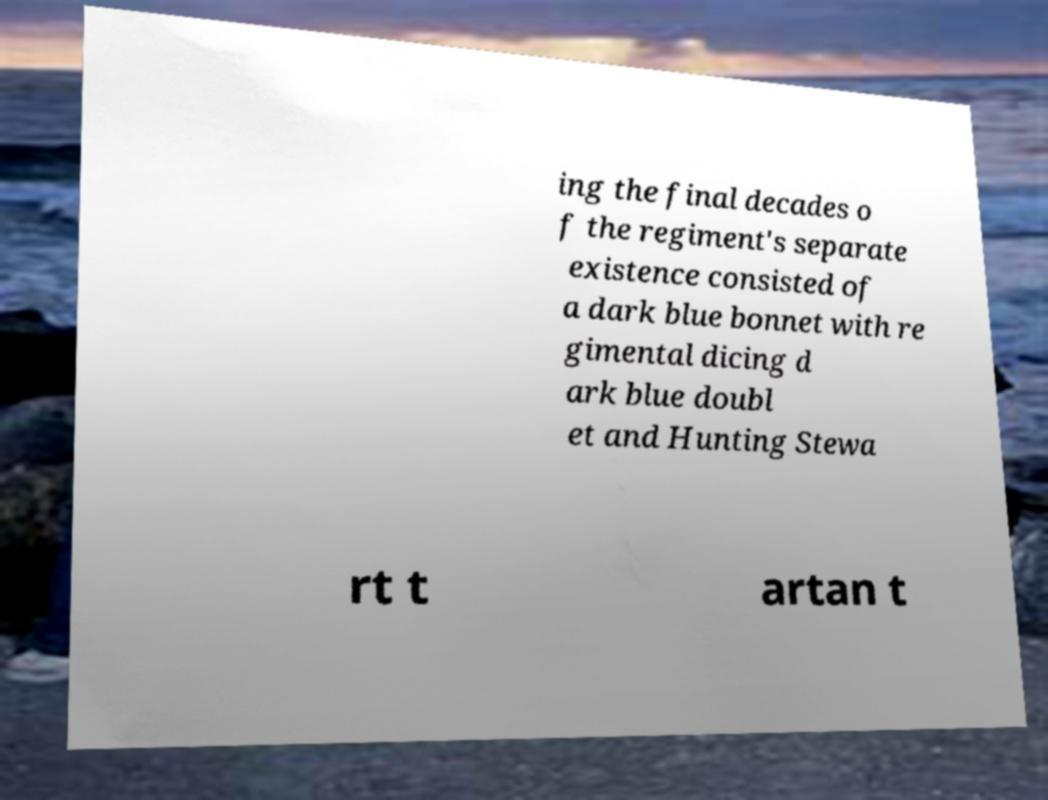Could you extract and type out the text from this image? ing the final decades o f the regiment's separate existence consisted of a dark blue bonnet with re gimental dicing d ark blue doubl et and Hunting Stewa rt t artan t 